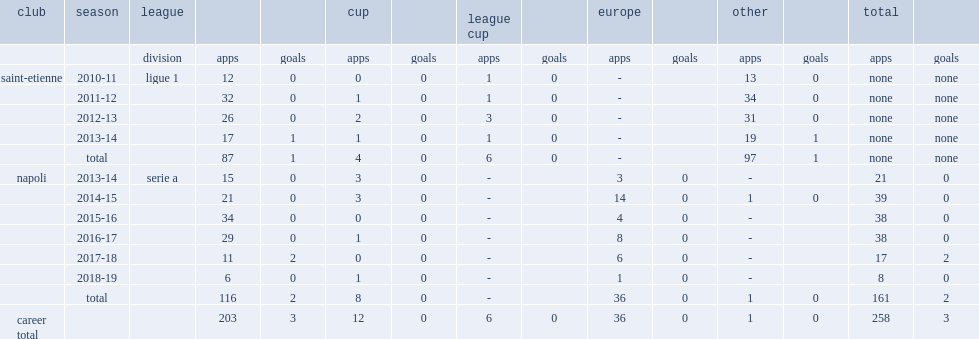Which club did faouzi ghoulam play for in 2013-14? Napoli. 